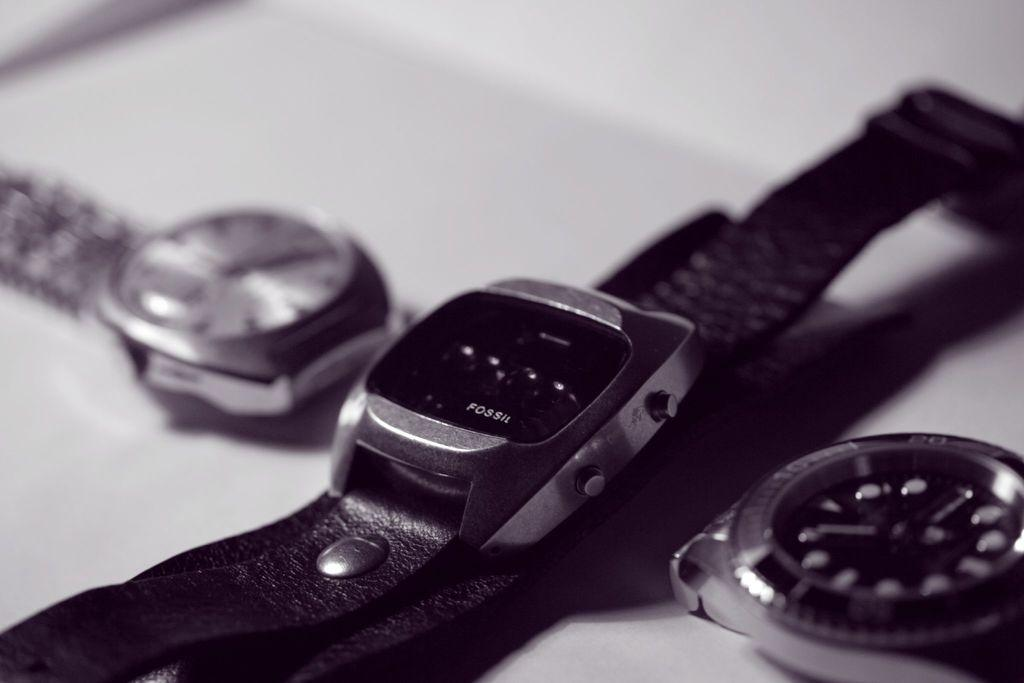<image>
Write a terse but informative summary of the picture. three watches are laying side by side with a Fossil watch in the center 